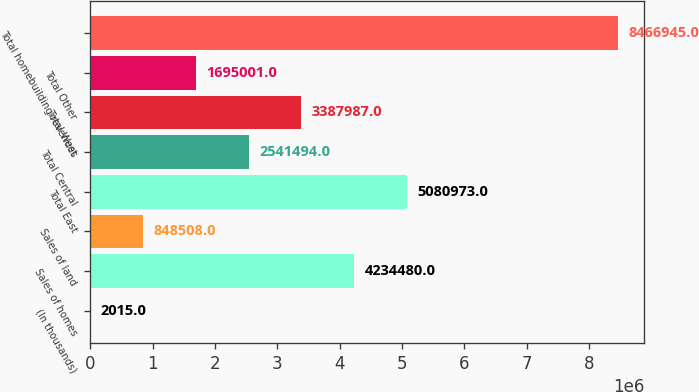Convert chart to OTSL. <chart><loc_0><loc_0><loc_500><loc_500><bar_chart><fcel>(In thousands)<fcel>Sales of homes<fcel>Sales of land<fcel>Total East<fcel>Total Central<fcel>Total West<fcel>Total Other<fcel>Total homebuilding revenues<nl><fcel>2015<fcel>4.23448e+06<fcel>848508<fcel>5.08097e+06<fcel>2.54149e+06<fcel>3.38799e+06<fcel>1.695e+06<fcel>8.46694e+06<nl></chart> 